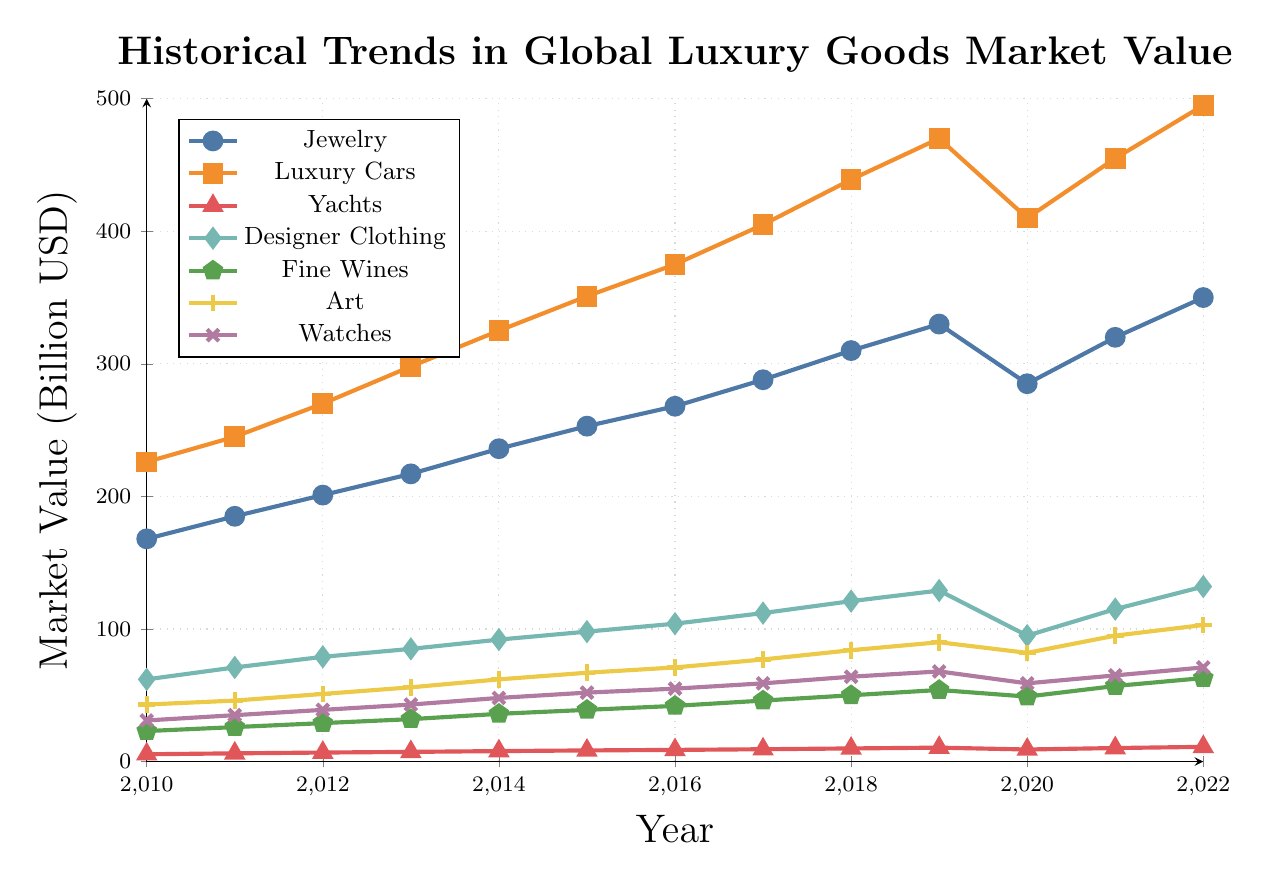What is the trend in the market value for luxury cars from 2010 to 2022? Observing the line representing luxury cars, it shows a consistent upward trend from 2010 to 2019. There’s a noticeable dip in 2020, but the upward trend resumes from 2021 to 2022.
Answer: Consistent upward trend with a slight dip in 2020 Which luxury goods category experienced the smallest drop in market value during 2020? By comparing the values from 2019 to 2020 for each category, yachts had a decrease from 10.5 to 9.1, which is a 1.4 decrease. This is the smallest drop among all categories.
Answer: Yachts How did the market value of fine wines change from 2010 to 2022? The fine wines category shows a gradual increase every year from 23 billion USD in 2010 to 63 billion USD in 2022, with a small dip in 2020.
Answer: Gradual increase with a small dip in 2020 Which category had the highest market value in 2022 and what was it? Referring to the lines in the figure, the line for luxury cars is at the top in 2022, with a market value of 495 billion USD.
Answer: Luxury Cars, 495 billion USD Compare the market value of designer clothing and fine wines in 2021. Which was higher and by how much? According to the figure, designer clothing had a market value of 115 billion USD, and fine wines had 57 billion USD in 2021. The difference is calculated as 115 - 57 = 58 billion USD.
Answer: Designer Clothing, 58 billion USD Which two categories had the largest market value in 2015 and what were their values? Looking at the values in 2015, luxury cars and jewelry had the highest values. Luxury cars were at 351 billion USD and jewelry at 253 billion USD.
Answer: Luxury Cars: 351 billion USD, Jewelry: 253 billion USD What was the lowest market value recorded for watches and in which year? From the figure, the lowest market value for watches was 31 billion USD in 2010.
Answer: 31 billion USD, 2010 Calculate the average market value of the art category between 2010 and 2022. Sum the values from 2010 to 2022 for the art category: 43 + 46 + 51 + 56 + 62 + 67 + 71 + 77 + 84 + 90 + 82 + 95 + 103 = 927. The number of years is 13. So, the average = 927 / 13 ≈ 71.31 billion USD.
Answer: 71.31 billion USD How did the market value of yachts in 2020 compare to its previous value in 2019? In 2019 the market value was 10.5 billion USD, and in 2020 it was 9.1 billion USD. The difference is 10.5 - 9.1 = 1.4 billion USD decrease.
Answer: Decreased by 1.4 billion USD 